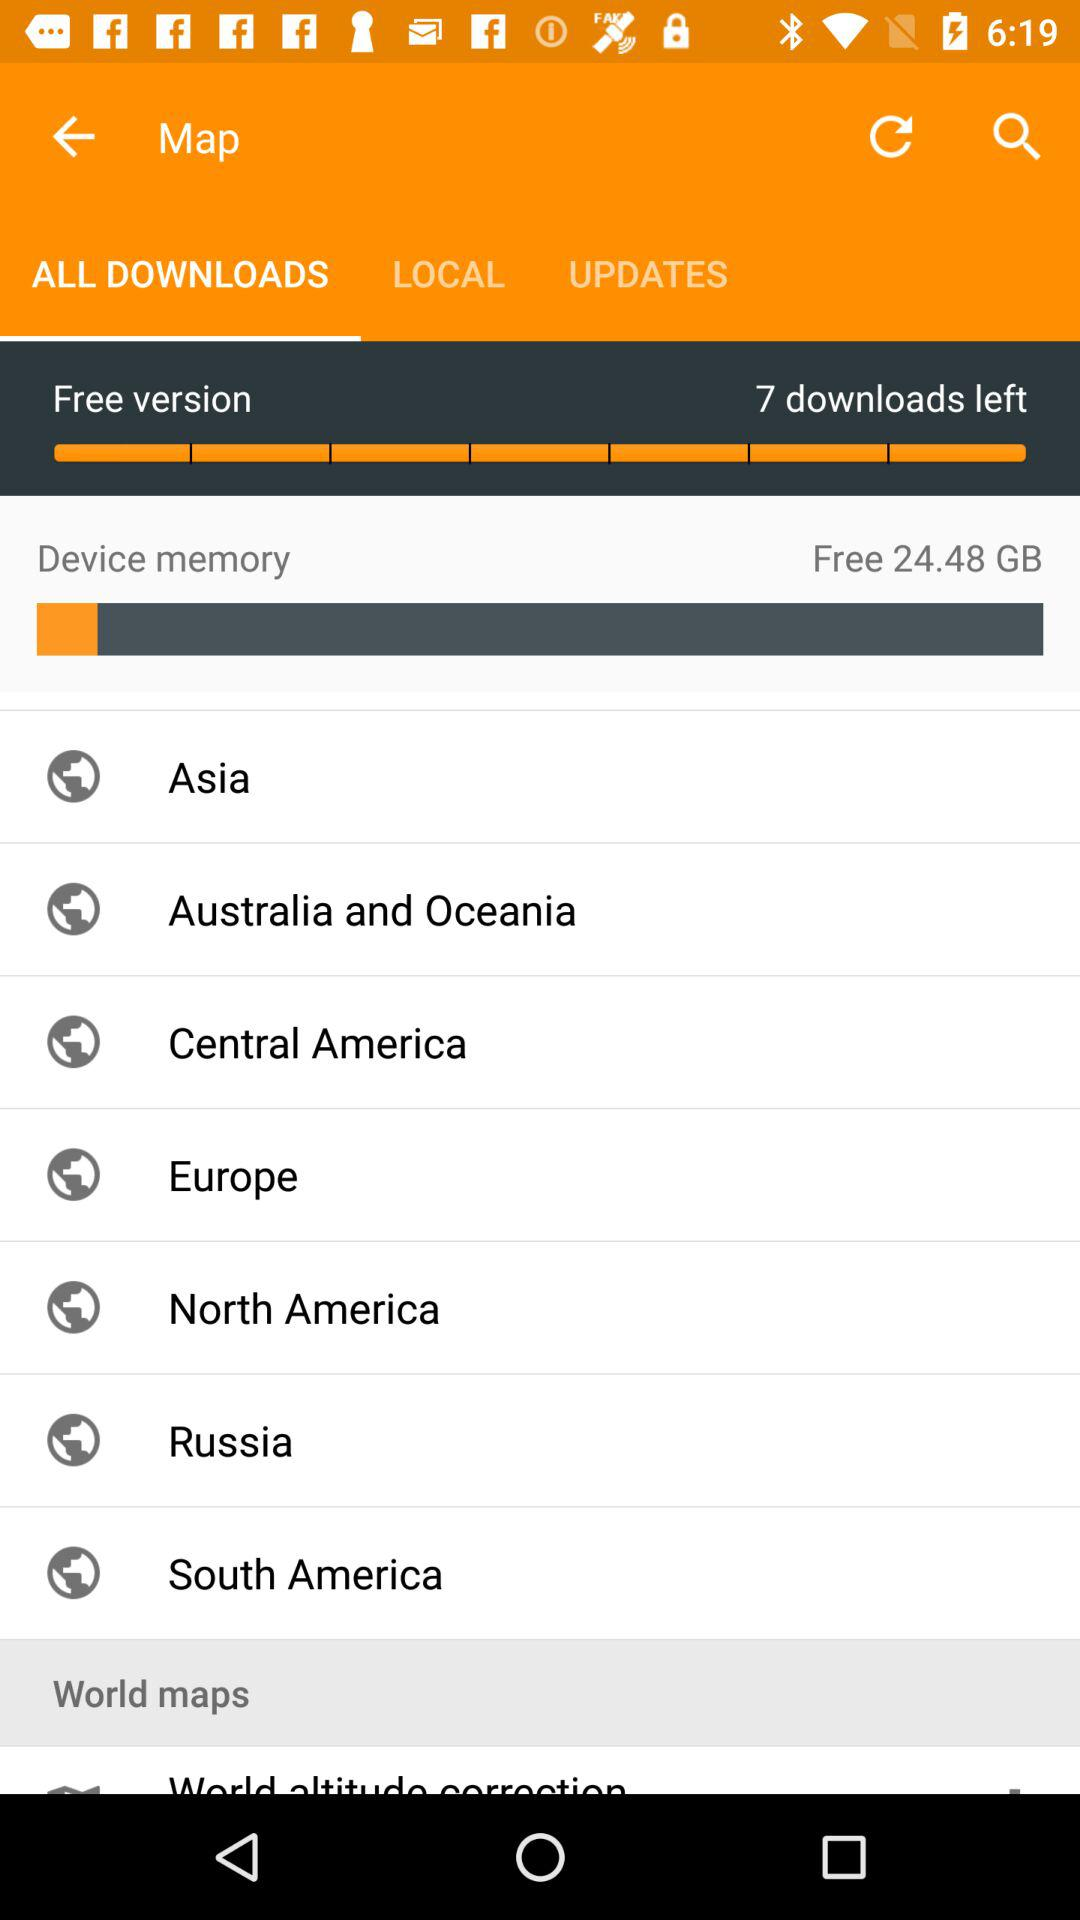How many downloads are left? There are 7 downloads left. 